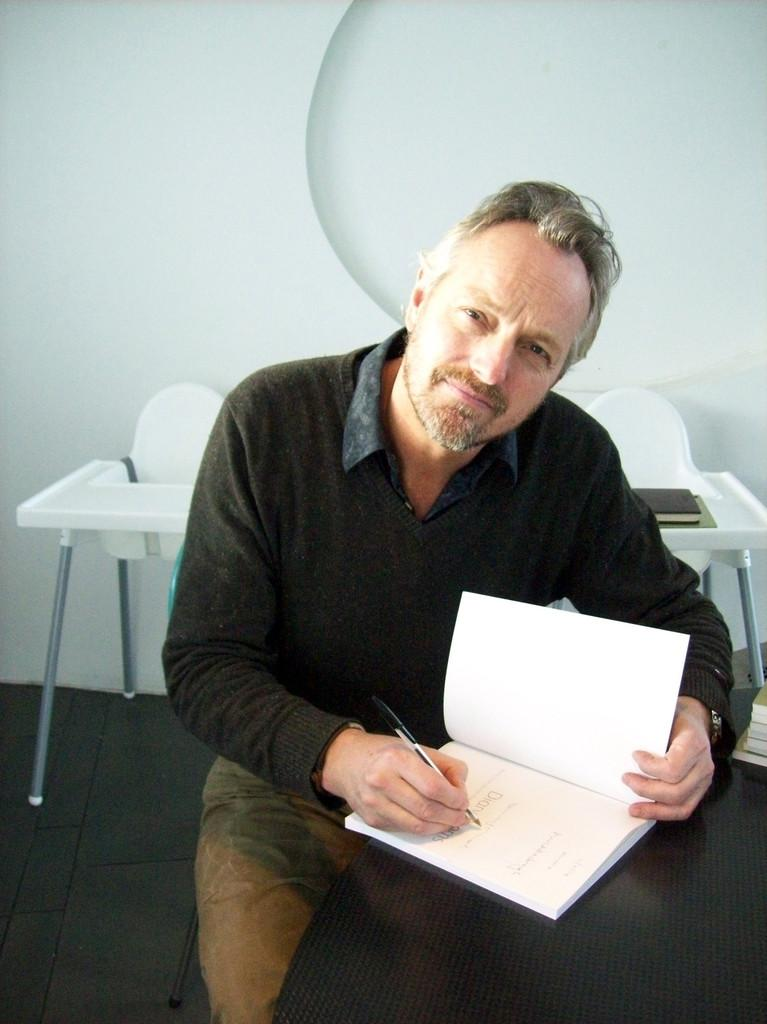Who is the person in the image? There is a man in the image. What is the man doing in the image? The man is sitting in a chair and writing with a pen. What is the man writing in? The man is writing in a book. Where is the book located? The book is on a table. What else can be seen in the background of the image? There is another table and a wall in the background. How many geese are present in the image? There are no geese present in the image. Is the man in the image a spy? There is no information in the image to suggest that the man is a spy. 